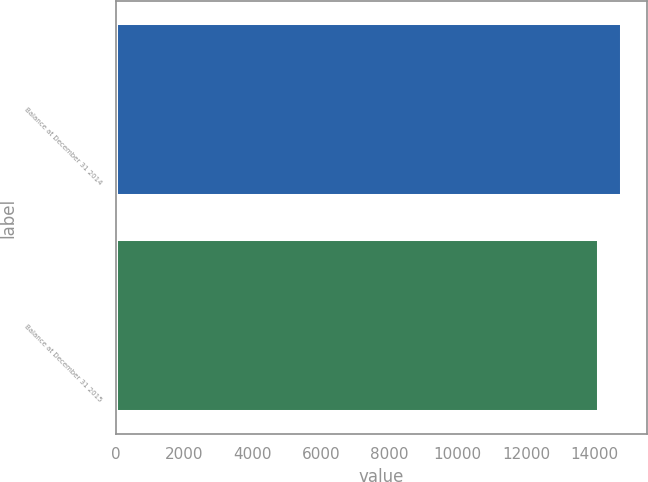<chart> <loc_0><loc_0><loc_500><loc_500><bar_chart><fcel>Balance at December 31 2014<fcel>Balance at December 31 2015<nl><fcel>14794<fcel>14131<nl></chart> 